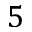<formula> <loc_0><loc_0><loc_500><loc_500>5</formula> 